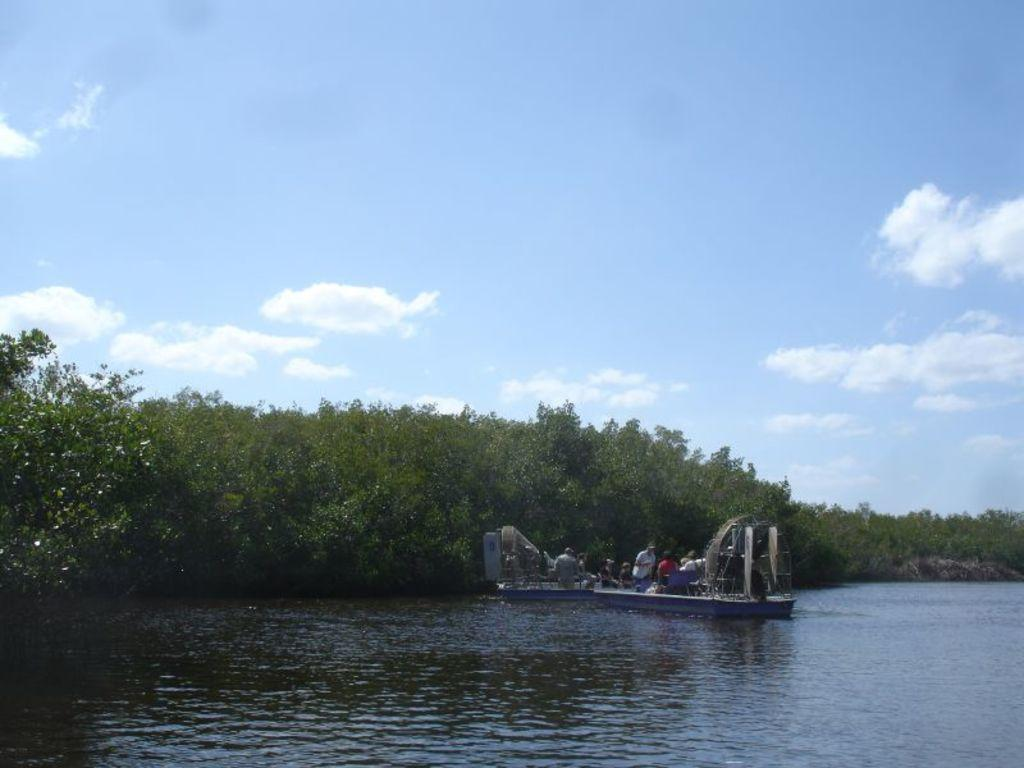Where was the image taken? The image was clicked outside the city. What can be seen in the water body in the image? There is a boat in the water body. How many people are in the boat? The boat contains some persons. What is visible in the background of the image? The sky, plants, and trees are present in the background. What type of magic is being performed by the boat in the image? There is no magic being performed in the image; it is a boat in a water body with people inside. What kind of wine is being served on the boat in the image? There is no wine or any indication of food or drink in the image; it only shows a boat with people inside. 